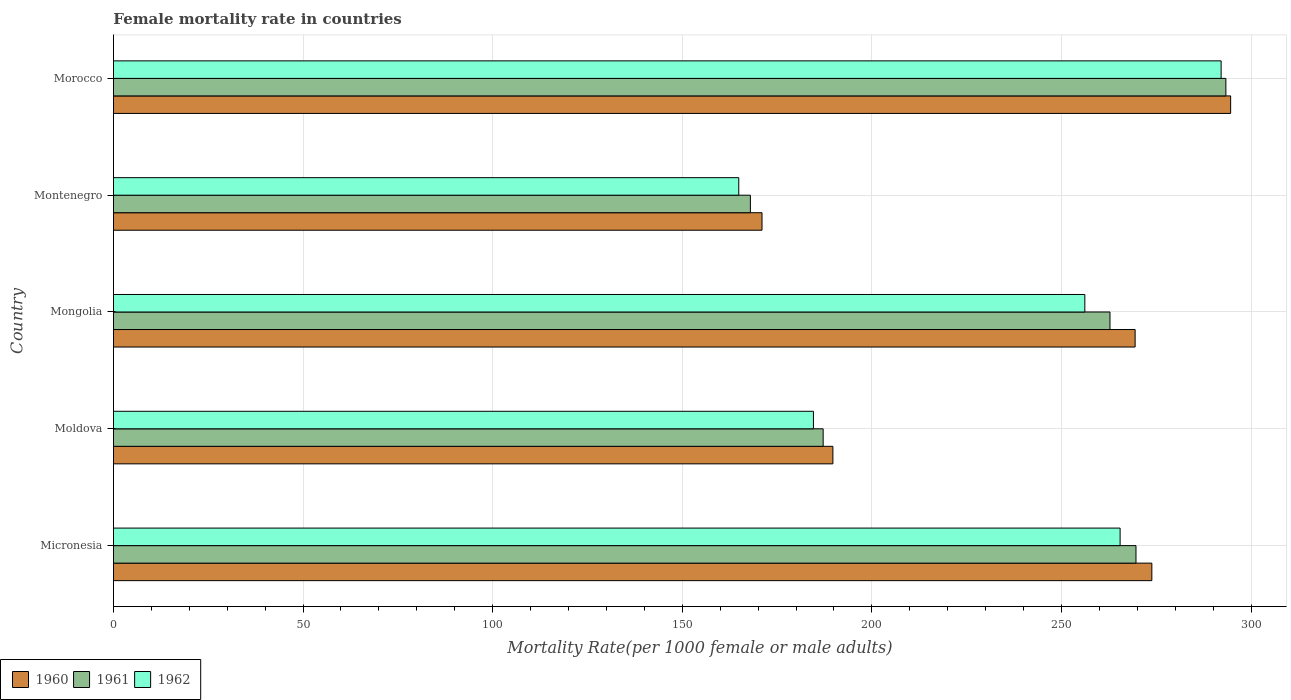How many different coloured bars are there?
Ensure brevity in your answer.  3. How many bars are there on the 5th tick from the top?
Provide a short and direct response. 3. How many bars are there on the 1st tick from the bottom?
Provide a succinct answer. 3. What is the label of the 5th group of bars from the top?
Your answer should be compact. Micronesia. What is the female mortality rate in 1960 in Montenegro?
Ensure brevity in your answer.  171.04. Across all countries, what is the maximum female mortality rate in 1960?
Your answer should be compact. 294.62. Across all countries, what is the minimum female mortality rate in 1962?
Offer a terse response. 164.9. In which country was the female mortality rate in 1961 maximum?
Offer a terse response. Morocco. In which country was the female mortality rate in 1961 minimum?
Your response must be concise. Montenegro. What is the total female mortality rate in 1961 in the graph?
Your response must be concise. 1180.96. What is the difference between the female mortality rate in 1961 in Moldova and that in Morocco?
Your answer should be compact. -106.21. What is the difference between the female mortality rate in 1960 in Moldova and the female mortality rate in 1962 in Morocco?
Make the answer very short. -102.39. What is the average female mortality rate in 1960 per country?
Give a very brief answer. 239.73. What is the difference between the female mortality rate in 1961 and female mortality rate in 1962 in Morocco?
Offer a very short reply. 1.25. In how many countries, is the female mortality rate in 1961 greater than 270 ?
Offer a terse response. 1. What is the ratio of the female mortality rate in 1960 in Moldova to that in Montenegro?
Provide a succinct answer. 1.11. Is the female mortality rate in 1960 in Mongolia less than that in Montenegro?
Offer a terse response. No. Is the difference between the female mortality rate in 1961 in Moldova and Morocco greater than the difference between the female mortality rate in 1962 in Moldova and Morocco?
Keep it short and to the point. Yes. What is the difference between the highest and the second highest female mortality rate in 1962?
Your answer should be very brief. 26.64. What is the difference between the highest and the lowest female mortality rate in 1960?
Your response must be concise. 123.59. What does the 2nd bar from the bottom in Micronesia represents?
Provide a succinct answer. 1961. Is it the case that in every country, the sum of the female mortality rate in 1962 and female mortality rate in 1961 is greater than the female mortality rate in 1960?
Give a very brief answer. Yes. How many bars are there?
Your answer should be compact. 15. Are all the bars in the graph horizontal?
Keep it short and to the point. Yes. What is the difference between two consecutive major ticks on the X-axis?
Give a very brief answer. 50. Are the values on the major ticks of X-axis written in scientific E-notation?
Your answer should be compact. No. Does the graph contain grids?
Offer a very short reply. Yes. How are the legend labels stacked?
Give a very brief answer. Horizontal. What is the title of the graph?
Provide a succinct answer. Female mortality rate in countries. Does "1976" appear as one of the legend labels in the graph?
Your answer should be compact. No. What is the label or title of the X-axis?
Your response must be concise. Mortality Rate(per 1000 female or male adults). What is the label or title of the Y-axis?
Provide a succinct answer. Country. What is the Mortality Rate(per 1000 female or male adults) in 1960 in Micronesia?
Give a very brief answer. 273.84. What is the Mortality Rate(per 1000 female or male adults) of 1961 in Micronesia?
Provide a short and direct response. 269.66. What is the Mortality Rate(per 1000 female or male adults) in 1962 in Micronesia?
Offer a very short reply. 265.48. What is the Mortality Rate(per 1000 female or male adults) in 1960 in Moldova?
Give a very brief answer. 189.73. What is the Mortality Rate(per 1000 female or male adults) of 1961 in Moldova?
Your response must be concise. 187.16. What is the Mortality Rate(per 1000 female or male adults) in 1962 in Moldova?
Provide a succinct answer. 184.59. What is the Mortality Rate(per 1000 female or male adults) in 1960 in Mongolia?
Provide a short and direct response. 269.44. What is the Mortality Rate(per 1000 female or male adults) in 1961 in Mongolia?
Provide a succinct answer. 262.8. What is the Mortality Rate(per 1000 female or male adults) of 1962 in Mongolia?
Offer a terse response. 256.17. What is the Mortality Rate(per 1000 female or male adults) of 1960 in Montenegro?
Your response must be concise. 171.04. What is the Mortality Rate(per 1000 female or male adults) in 1961 in Montenegro?
Make the answer very short. 167.97. What is the Mortality Rate(per 1000 female or male adults) of 1962 in Montenegro?
Your response must be concise. 164.9. What is the Mortality Rate(per 1000 female or male adults) in 1960 in Morocco?
Provide a succinct answer. 294.62. What is the Mortality Rate(per 1000 female or male adults) in 1961 in Morocco?
Provide a succinct answer. 293.37. What is the Mortality Rate(per 1000 female or male adults) in 1962 in Morocco?
Your answer should be very brief. 292.11. Across all countries, what is the maximum Mortality Rate(per 1000 female or male adults) of 1960?
Give a very brief answer. 294.62. Across all countries, what is the maximum Mortality Rate(per 1000 female or male adults) in 1961?
Your response must be concise. 293.37. Across all countries, what is the maximum Mortality Rate(per 1000 female or male adults) in 1962?
Your response must be concise. 292.11. Across all countries, what is the minimum Mortality Rate(per 1000 female or male adults) of 1960?
Keep it short and to the point. 171.04. Across all countries, what is the minimum Mortality Rate(per 1000 female or male adults) in 1961?
Give a very brief answer. 167.97. Across all countries, what is the minimum Mortality Rate(per 1000 female or male adults) in 1962?
Offer a terse response. 164.9. What is the total Mortality Rate(per 1000 female or male adults) in 1960 in the graph?
Keep it short and to the point. 1198.67. What is the total Mortality Rate(per 1000 female or male adults) in 1961 in the graph?
Provide a succinct answer. 1180.96. What is the total Mortality Rate(per 1000 female or male adults) in 1962 in the graph?
Your answer should be compact. 1163.26. What is the difference between the Mortality Rate(per 1000 female or male adults) in 1960 in Micronesia and that in Moldova?
Offer a terse response. 84.12. What is the difference between the Mortality Rate(per 1000 female or male adults) in 1961 in Micronesia and that in Moldova?
Your answer should be very brief. 82.5. What is the difference between the Mortality Rate(per 1000 female or male adults) in 1962 in Micronesia and that in Moldova?
Offer a very short reply. 80.88. What is the difference between the Mortality Rate(per 1000 female or male adults) in 1960 in Micronesia and that in Mongolia?
Make the answer very short. 4.41. What is the difference between the Mortality Rate(per 1000 female or male adults) in 1961 in Micronesia and that in Mongolia?
Provide a succinct answer. 6.86. What is the difference between the Mortality Rate(per 1000 female or male adults) in 1962 in Micronesia and that in Mongolia?
Offer a very short reply. 9.3. What is the difference between the Mortality Rate(per 1000 female or male adults) in 1960 in Micronesia and that in Montenegro?
Your response must be concise. 102.81. What is the difference between the Mortality Rate(per 1000 female or male adults) in 1961 in Micronesia and that in Montenegro?
Provide a succinct answer. 101.69. What is the difference between the Mortality Rate(per 1000 female or male adults) of 1962 in Micronesia and that in Montenegro?
Give a very brief answer. 100.57. What is the difference between the Mortality Rate(per 1000 female or male adults) of 1960 in Micronesia and that in Morocco?
Offer a terse response. -20.78. What is the difference between the Mortality Rate(per 1000 female or male adults) of 1961 in Micronesia and that in Morocco?
Keep it short and to the point. -23.71. What is the difference between the Mortality Rate(per 1000 female or male adults) of 1962 in Micronesia and that in Morocco?
Make the answer very short. -26.64. What is the difference between the Mortality Rate(per 1000 female or male adults) in 1960 in Moldova and that in Mongolia?
Make the answer very short. -79.71. What is the difference between the Mortality Rate(per 1000 female or male adults) of 1961 in Moldova and that in Mongolia?
Your response must be concise. -75.64. What is the difference between the Mortality Rate(per 1000 female or male adults) of 1962 in Moldova and that in Mongolia?
Your answer should be compact. -71.58. What is the difference between the Mortality Rate(per 1000 female or male adults) in 1960 in Moldova and that in Montenegro?
Provide a succinct answer. 18.69. What is the difference between the Mortality Rate(per 1000 female or male adults) in 1961 in Moldova and that in Montenegro?
Make the answer very short. 19.19. What is the difference between the Mortality Rate(per 1000 female or male adults) in 1962 in Moldova and that in Montenegro?
Offer a very short reply. 19.69. What is the difference between the Mortality Rate(per 1000 female or male adults) of 1960 in Moldova and that in Morocco?
Keep it short and to the point. -104.9. What is the difference between the Mortality Rate(per 1000 female or male adults) of 1961 in Moldova and that in Morocco?
Ensure brevity in your answer.  -106.21. What is the difference between the Mortality Rate(per 1000 female or male adults) in 1962 in Moldova and that in Morocco?
Offer a very short reply. -107.52. What is the difference between the Mortality Rate(per 1000 female or male adults) in 1960 in Mongolia and that in Montenegro?
Provide a succinct answer. 98.4. What is the difference between the Mortality Rate(per 1000 female or male adults) in 1961 in Mongolia and that in Montenegro?
Keep it short and to the point. 94.83. What is the difference between the Mortality Rate(per 1000 female or male adults) of 1962 in Mongolia and that in Montenegro?
Keep it short and to the point. 91.27. What is the difference between the Mortality Rate(per 1000 female or male adults) of 1960 in Mongolia and that in Morocco?
Give a very brief answer. -25.19. What is the difference between the Mortality Rate(per 1000 female or male adults) in 1961 in Mongolia and that in Morocco?
Offer a very short reply. -30.57. What is the difference between the Mortality Rate(per 1000 female or male adults) of 1962 in Mongolia and that in Morocco?
Keep it short and to the point. -35.94. What is the difference between the Mortality Rate(per 1000 female or male adults) of 1960 in Montenegro and that in Morocco?
Your answer should be very brief. -123.59. What is the difference between the Mortality Rate(per 1000 female or male adults) of 1961 in Montenegro and that in Morocco?
Your answer should be very brief. -125.4. What is the difference between the Mortality Rate(per 1000 female or male adults) in 1962 in Montenegro and that in Morocco?
Ensure brevity in your answer.  -127.21. What is the difference between the Mortality Rate(per 1000 female or male adults) of 1960 in Micronesia and the Mortality Rate(per 1000 female or male adults) of 1961 in Moldova?
Keep it short and to the point. 86.68. What is the difference between the Mortality Rate(per 1000 female or male adults) in 1960 in Micronesia and the Mortality Rate(per 1000 female or male adults) in 1962 in Moldova?
Offer a very short reply. 89.25. What is the difference between the Mortality Rate(per 1000 female or male adults) of 1961 in Micronesia and the Mortality Rate(per 1000 female or male adults) of 1962 in Moldova?
Ensure brevity in your answer.  85.06. What is the difference between the Mortality Rate(per 1000 female or male adults) in 1960 in Micronesia and the Mortality Rate(per 1000 female or male adults) in 1961 in Mongolia?
Give a very brief answer. 11.04. What is the difference between the Mortality Rate(per 1000 female or male adults) of 1960 in Micronesia and the Mortality Rate(per 1000 female or male adults) of 1962 in Mongolia?
Provide a succinct answer. 17.67. What is the difference between the Mortality Rate(per 1000 female or male adults) in 1961 in Micronesia and the Mortality Rate(per 1000 female or male adults) in 1962 in Mongolia?
Provide a succinct answer. 13.49. What is the difference between the Mortality Rate(per 1000 female or male adults) of 1960 in Micronesia and the Mortality Rate(per 1000 female or male adults) of 1961 in Montenegro?
Keep it short and to the point. 105.87. What is the difference between the Mortality Rate(per 1000 female or male adults) of 1960 in Micronesia and the Mortality Rate(per 1000 female or male adults) of 1962 in Montenegro?
Make the answer very short. 108.94. What is the difference between the Mortality Rate(per 1000 female or male adults) of 1961 in Micronesia and the Mortality Rate(per 1000 female or male adults) of 1962 in Montenegro?
Provide a succinct answer. 104.76. What is the difference between the Mortality Rate(per 1000 female or male adults) of 1960 in Micronesia and the Mortality Rate(per 1000 female or male adults) of 1961 in Morocco?
Offer a very short reply. -19.52. What is the difference between the Mortality Rate(per 1000 female or male adults) of 1960 in Micronesia and the Mortality Rate(per 1000 female or male adults) of 1962 in Morocco?
Provide a short and direct response. -18.27. What is the difference between the Mortality Rate(per 1000 female or male adults) in 1961 in Micronesia and the Mortality Rate(per 1000 female or male adults) in 1962 in Morocco?
Give a very brief answer. -22.45. What is the difference between the Mortality Rate(per 1000 female or male adults) of 1960 in Moldova and the Mortality Rate(per 1000 female or male adults) of 1961 in Mongolia?
Your answer should be compact. -73.08. What is the difference between the Mortality Rate(per 1000 female or male adults) of 1960 in Moldova and the Mortality Rate(per 1000 female or male adults) of 1962 in Mongolia?
Your answer should be compact. -66.44. What is the difference between the Mortality Rate(per 1000 female or male adults) in 1961 in Moldova and the Mortality Rate(per 1000 female or male adults) in 1962 in Mongolia?
Provide a short and direct response. -69.01. What is the difference between the Mortality Rate(per 1000 female or male adults) of 1960 in Moldova and the Mortality Rate(per 1000 female or male adults) of 1961 in Montenegro?
Make the answer very short. 21.76. What is the difference between the Mortality Rate(per 1000 female or male adults) in 1960 in Moldova and the Mortality Rate(per 1000 female or male adults) in 1962 in Montenegro?
Make the answer very short. 24.82. What is the difference between the Mortality Rate(per 1000 female or male adults) in 1961 in Moldova and the Mortality Rate(per 1000 female or male adults) in 1962 in Montenegro?
Your answer should be very brief. 22.26. What is the difference between the Mortality Rate(per 1000 female or male adults) in 1960 in Moldova and the Mortality Rate(per 1000 female or male adults) in 1961 in Morocco?
Make the answer very short. -103.64. What is the difference between the Mortality Rate(per 1000 female or male adults) in 1960 in Moldova and the Mortality Rate(per 1000 female or male adults) in 1962 in Morocco?
Offer a very short reply. -102.39. What is the difference between the Mortality Rate(per 1000 female or male adults) of 1961 in Moldova and the Mortality Rate(per 1000 female or male adults) of 1962 in Morocco?
Your answer should be very brief. -104.95. What is the difference between the Mortality Rate(per 1000 female or male adults) in 1960 in Mongolia and the Mortality Rate(per 1000 female or male adults) in 1961 in Montenegro?
Give a very brief answer. 101.47. What is the difference between the Mortality Rate(per 1000 female or male adults) of 1960 in Mongolia and the Mortality Rate(per 1000 female or male adults) of 1962 in Montenegro?
Your response must be concise. 104.53. What is the difference between the Mortality Rate(per 1000 female or male adults) of 1961 in Mongolia and the Mortality Rate(per 1000 female or male adults) of 1962 in Montenegro?
Ensure brevity in your answer.  97.9. What is the difference between the Mortality Rate(per 1000 female or male adults) in 1960 in Mongolia and the Mortality Rate(per 1000 female or male adults) in 1961 in Morocco?
Ensure brevity in your answer.  -23.93. What is the difference between the Mortality Rate(per 1000 female or male adults) of 1960 in Mongolia and the Mortality Rate(per 1000 female or male adults) of 1962 in Morocco?
Make the answer very short. -22.68. What is the difference between the Mortality Rate(per 1000 female or male adults) in 1961 in Mongolia and the Mortality Rate(per 1000 female or male adults) in 1962 in Morocco?
Give a very brief answer. -29.31. What is the difference between the Mortality Rate(per 1000 female or male adults) of 1960 in Montenegro and the Mortality Rate(per 1000 female or male adults) of 1961 in Morocco?
Your response must be concise. -122.33. What is the difference between the Mortality Rate(per 1000 female or male adults) in 1960 in Montenegro and the Mortality Rate(per 1000 female or male adults) in 1962 in Morocco?
Ensure brevity in your answer.  -121.08. What is the difference between the Mortality Rate(per 1000 female or male adults) of 1961 in Montenegro and the Mortality Rate(per 1000 female or male adults) of 1962 in Morocco?
Your answer should be compact. -124.14. What is the average Mortality Rate(per 1000 female or male adults) in 1960 per country?
Your response must be concise. 239.73. What is the average Mortality Rate(per 1000 female or male adults) of 1961 per country?
Offer a terse response. 236.19. What is the average Mortality Rate(per 1000 female or male adults) in 1962 per country?
Offer a terse response. 232.65. What is the difference between the Mortality Rate(per 1000 female or male adults) of 1960 and Mortality Rate(per 1000 female or male adults) of 1961 in Micronesia?
Ensure brevity in your answer.  4.18. What is the difference between the Mortality Rate(per 1000 female or male adults) in 1960 and Mortality Rate(per 1000 female or male adults) in 1962 in Micronesia?
Your answer should be compact. 8.37. What is the difference between the Mortality Rate(per 1000 female or male adults) of 1961 and Mortality Rate(per 1000 female or male adults) of 1962 in Micronesia?
Give a very brief answer. 4.18. What is the difference between the Mortality Rate(per 1000 female or male adults) in 1960 and Mortality Rate(per 1000 female or male adults) in 1961 in Moldova?
Your answer should be very brief. 2.57. What is the difference between the Mortality Rate(per 1000 female or male adults) of 1960 and Mortality Rate(per 1000 female or male adults) of 1962 in Moldova?
Offer a terse response. 5.13. What is the difference between the Mortality Rate(per 1000 female or male adults) in 1961 and Mortality Rate(per 1000 female or male adults) in 1962 in Moldova?
Give a very brief answer. 2.57. What is the difference between the Mortality Rate(per 1000 female or male adults) in 1960 and Mortality Rate(per 1000 female or male adults) in 1961 in Mongolia?
Give a very brief answer. 6.63. What is the difference between the Mortality Rate(per 1000 female or male adults) in 1960 and Mortality Rate(per 1000 female or male adults) in 1962 in Mongolia?
Your answer should be compact. 13.27. What is the difference between the Mortality Rate(per 1000 female or male adults) of 1961 and Mortality Rate(per 1000 female or male adults) of 1962 in Mongolia?
Offer a terse response. 6.63. What is the difference between the Mortality Rate(per 1000 female or male adults) of 1960 and Mortality Rate(per 1000 female or male adults) of 1961 in Montenegro?
Make the answer very short. 3.07. What is the difference between the Mortality Rate(per 1000 female or male adults) in 1960 and Mortality Rate(per 1000 female or male adults) in 1962 in Montenegro?
Ensure brevity in your answer.  6.13. What is the difference between the Mortality Rate(per 1000 female or male adults) in 1961 and Mortality Rate(per 1000 female or male adults) in 1962 in Montenegro?
Make the answer very short. 3.07. What is the difference between the Mortality Rate(per 1000 female or male adults) of 1960 and Mortality Rate(per 1000 female or male adults) of 1961 in Morocco?
Offer a very short reply. 1.25. What is the difference between the Mortality Rate(per 1000 female or male adults) in 1960 and Mortality Rate(per 1000 female or male adults) in 1962 in Morocco?
Provide a short and direct response. 2.51. What is the difference between the Mortality Rate(per 1000 female or male adults) of 1961 and Mortality Rate(per 1000 female or male adults) of 1962 in Morocco?
Give a very brief answer. 1.25. What is the ratio of the Mortality Rate(per 1000 female or male adults) of 1960 in Micronesia to that in Moldova?
Make the answer very short. 1.44. What is the ratio of the Mortality Rate(per 1000 female or male adults) of 1961 in Micronesia to that in Moldova?
Your answer should be compact. 1.44. What is the ratio of the Mortality Rate(per 1000 female or male adults) of 1962 in Micronesia to that in Moldova?
Keep it short and to the point. 1.44. What is the ratio of the Mortality Rate(per 1000 female or male adults) of 1960 in Micronesia to that in Mongolia?
Offer a very short reply. 1.02. What is the ratio of the Mortality Rate(per 1000 female or male adults) in 1961 in Micronesia to that in Mongolia?
Your answer should be very brief. 1.03. What is the ratio of the Mortality Rate(per 1000 female or male adults) in 1962 in Micronesia to that in Mongolia?
Your answer should be compact. 1.04. What is the ratio of the Mortality Rate(per 1000 female or male adults) of 1960 in Micronesia to that in Montenegro?
Keep it short and to the point. 1.6. What is the ratio of the Mortality Rate(per 1000 female or male adults) in 1961 in Micronesia to that in Montenegro?
Keep it short and to the point. 1.61. What is the ratio of the Mortality Rate(per 1000 female or male adults) of 1962 in Micronesia to that in Montenegro?
Keep it short and to the point. 1.61. What is the ratio of the Mortality Rate(per 1000 female or male adults) of 1960 in Micronesia to that in Morocco?
Provide a short and direct response. 0.93. What is the ratio of the Mortality Rate(per 1000 female or male adults) of 1961 in Micronesia to that in Morocco?
Offer a very short reply. 0.92. What is the ratio of the Mortality Rate(per 1000 female or male adults) in 1962 in Micronesia to that in Morocco?
Your answer should be compact. 0.91. What is the ratio of the Mortality Rate(per 1000 female or male adults) of 1960 in Moldova to that in Mongolia?
Keep it short and to the point. 0.7. What is the ratio of the Mortality Rate(per 1000 female or male adults) in 1961 in Moldova to that in Mongolia?
Keep it short and to the point. 0.71. What is the ratio of the Mortality Rate(per 1000 female or male adults) of 1962 in Moldova to that in Mongolia?
Your answer should be compact. 0.72. What is the ratio of the Mortality Rate(per 1000 female or male adults) of 1960 in Moldova to that in Montenegro?
Provide a short and direct response. 1.11. What is the ratio of the Mortality Rate(per 1000 female or male adults) in 1961 in Moldova to that in Montenegro?
Offer a terse response. 1.11. What is the ratio of the Mortality Rate(per 1000 female or male adults) in 1962 in Moldova to that in Montenegro?
Your answer should be compact. 1.12. What is the ratio of the Mortality Rate(per 1000 female or male adults) in 1960 in Moldova to that in Morocco?
Offer a terse response. 0.64. What is the ratio of the Mortality Rate(per 1000 female or male adults) in 1961 in Moldova to that in Morocco?
Keep it short and to the point. 0.64. What is the ratio of the Mortality Rate(per 1000 female or male adults) in 1962 in Moldova to that in Morocco?
Your answer should be very brief. 0.63. What is the ratio of the Mortality Rate(per 1000 female or male adults) in 1960 in Mongolia to that in Montenegro?
Offer a very short reply. 1.58. What is the ratio of the Mortality Rate(per 1000 female or male adults) of 1961 in Mongolia to that in Montenegro?
Keep it short and to the point. 1.56. What is the ratio of the Mortality Rate(per 1000 female or male adults) in 1962 in Mongolia to that in Montenegro?
Ensure brevity in your answer.  1.55. What is the ratio of the Mortality Rate(per 1000 female or male adults) of 1960 in Mongolia to that in Morocco?
Make the answer very short. 0.91. What is the ratio of the Mortality Rate(per 1000 female or male adults) of 1961 in Mongolia to that in Morocco?
Give a very brief answer. 0.9. What is the ratio of the Mortality Rate(per 1000 female or male adults) of 1962 in Mongolia to that in Morocco?
Ensure brevity in your answer.  0.88. What is the ratio of the Mortality Rate(per 1000 female or male adults) of 1960 in Montenegro to that in Morocco?
Provide a succinct answer. 0.58. What is the ratio of the Mortality Rate(per 1000 female or male adults) of 1961 in Montenegro to that in Morocco?
Offer a terse response. 0.57. What is the ratio of the Mortality Rate(per 1000 female or male adults) in 1962 in Montenegro to that in Morocco?
Provide a short and direct response. 0.56. What is the difference between the highest and the second highest Mortality Rate(per 1000 female or male adults) of 1960?
Your answer should be compact. 20.78. What is the difference between the highest and the second highest Mortality Rate(per 1000 female or male adults) of 1961?
Provide a succinct answer. 23.71. What is the difference between the highest and the second highest Mortality Rate(per 1000 female or male adults) in 1962?
Your answer should be very brief. 26.64. What is the difference between the highest and the lowest Mortality Rate(per 1000 female or male adults) of 1960?
Make the answer very short. 123.59. What is the difference between the highest and the lowest Mortality Rate(per 1000 female or male adults) in 1961?
Keep it short and to the point. 125.4. What is the difference between the highest and the lowest Mortality Rate(per 1000 female or male adults) of 1962?
Offer a terse response. 127.21. 